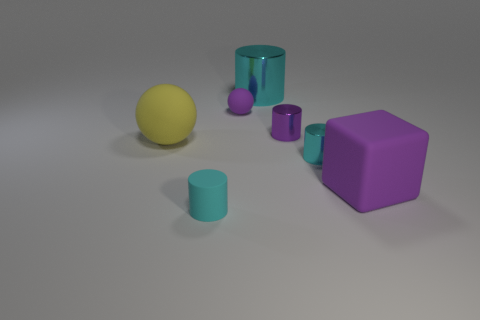Is the cyan thing that is behind the tiny purple sphere made of the same material as the tiny purple cylinder?
Your answer should be very brief. Yes. There is a tiny matte ball that is left of the small cyan cylinder behind the purple block; are there any objects in front of it?
Offer a very short reply. Yes. There is a cyan metallic object on the left side of the tiny purple metal cylinder; is it the same shape as the big purple thing?
Ensure brevity in your answer.  No. What shape is the object that is on the left side of the cylinder in front of the big purple rubber object?
Make the answer very short. Sphere. What size is the matte thing that is in front of the matte thing that is on the right side of the cyan shiny cylinder in front of the big rubber sphere?
Offer a terse response. Small. What color is the large thing that is the same shape as the small cyan rubber object?
Provide a short and direct response. Cyan. Do the matte cylinder and the purple rubber block have the same size?
Give a very brief answer. No. What is the material of the cylinder to the left of the big cyan thing?
Ensure brevity in your answer.  Rubber. How many other things are there of the same shape as the big cyan object?
Provide a short and direct response. 3. Do the small cyan rubber object and the big shiny object have the same shape?
Give a very brief answer. Yes. 